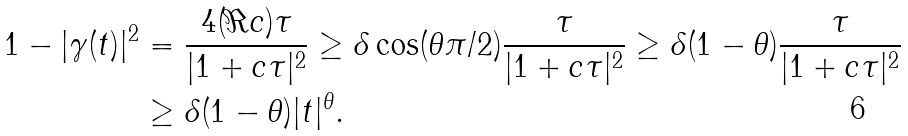<formula> <loc_0><loc_0><loc_500><loc_500>1 - | \gamma ( t ) | ^ { 2 } & = \frac { 4 ( \Re c ) \tau } { | 1 + c \tau | ^ { 2 } } \geq \delta \cos ( \theta \pi / 2 ) \frac { \tau } { | 1 + c \tau | ^ { 2 } } \geq \delta ( 1 - \theta ) \frac { \tau } { | 1 + c \tau | ^ { 2 } } \\ & \geq \delta ( 1 - \theta ) | t | ^ { \theta } .</formula> 